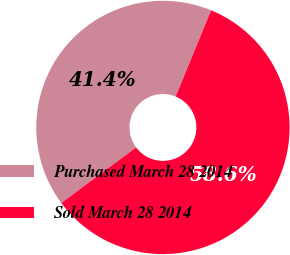Convert chart to OTSL. <chart><loc_0><loc_0><loc_500><loc_500><pie_chart><fcel>Purchased March 28 2014<fcel>Sold March 28 2014<nl><fcel>41.39%<fcel>58.61%<nl></chart> 